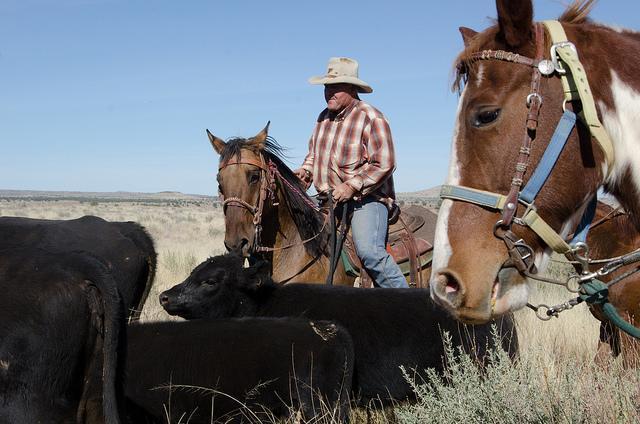How did this man get to this location?
Select the accurate response from the four choices given to answer the question.
Options: Walk, uber, via horseback, cow back. Via horseback. 